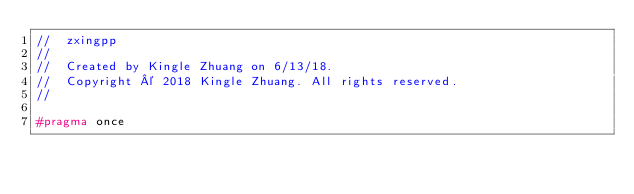Convert code to text. <code><loc_0><loc_0><loc_500><loc_500><_C++_>//  zxingpp
//
//  Created by Kingle Zhuang on 6/13/18.
//  Copyright © 2018 Kingle Zhuang. All rights reserved.
//

#pragma once
</code> 